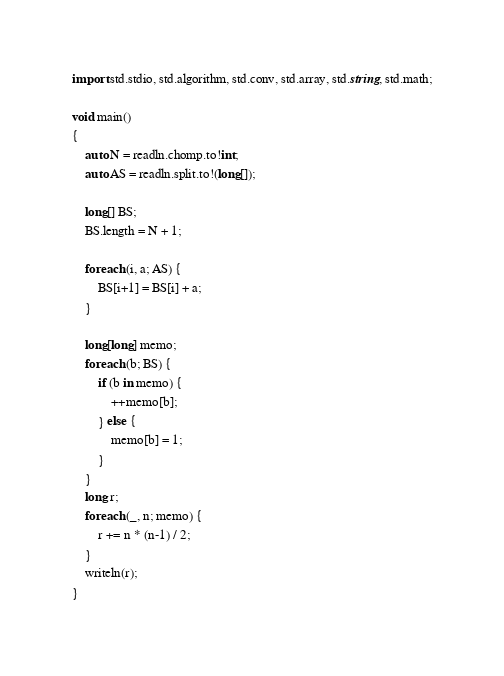Convert code to text. <code><loc_0><loc_0><loc_500><loc_500><_D_>import std.stdio, std.algorithm, std.conv, std.array, std.string, std.math;

void main()
{
    auto N = readln.chomp.to!int;
    auto AS = readln.split.to!(long[]);

    long[] BS;
    BS.length = N + 1;

    foreach (i, a; AS) {
        BS[i+1] = BS[i] + a;
    }

    long[long] memo;
    foreach (b; BS) {
        if (b in memo) {
            ++memo[b];
        } else {
            memo[b] = 1;
        }
    }
    long r;
    foreach (_, n; memo) {
        r += n * (n-1) / 2;
    }
    writeln(r);
}</code> 